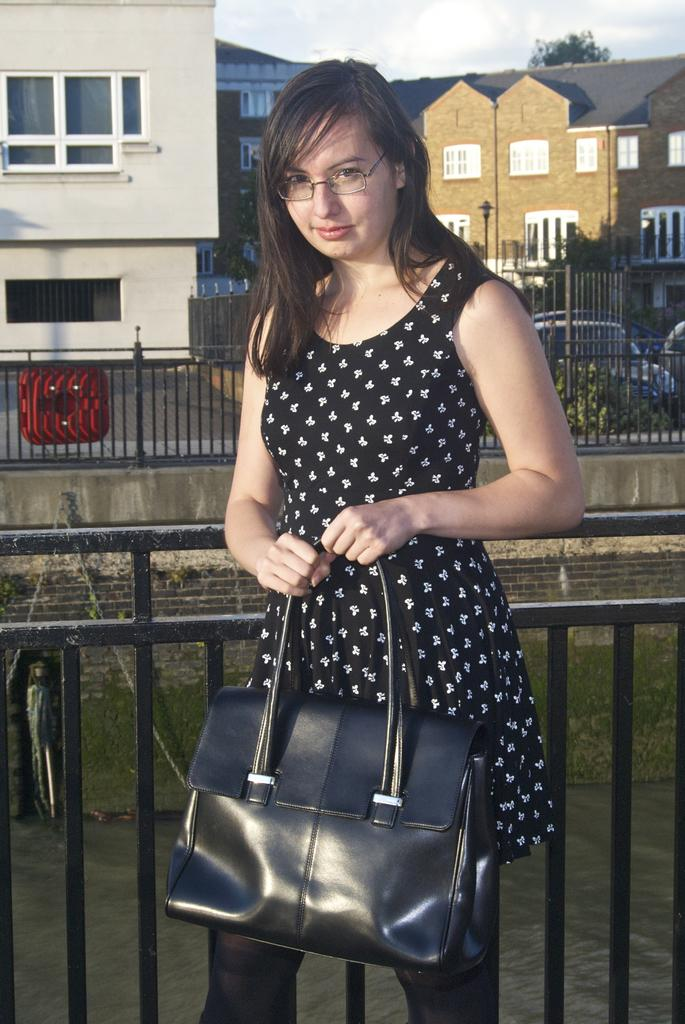What is the main subject of the image? There is a woman standing in the center of the image. What is the woman holding in the image? The woman is holding a handbag. What can be seen in the background of the image? There is a sky with clouds, a tree, a building, a fence, a wall, and grass in the background of the image. What type of books can be seen on the copper shelves in the image? There are no books or copper shelves present in the image. 